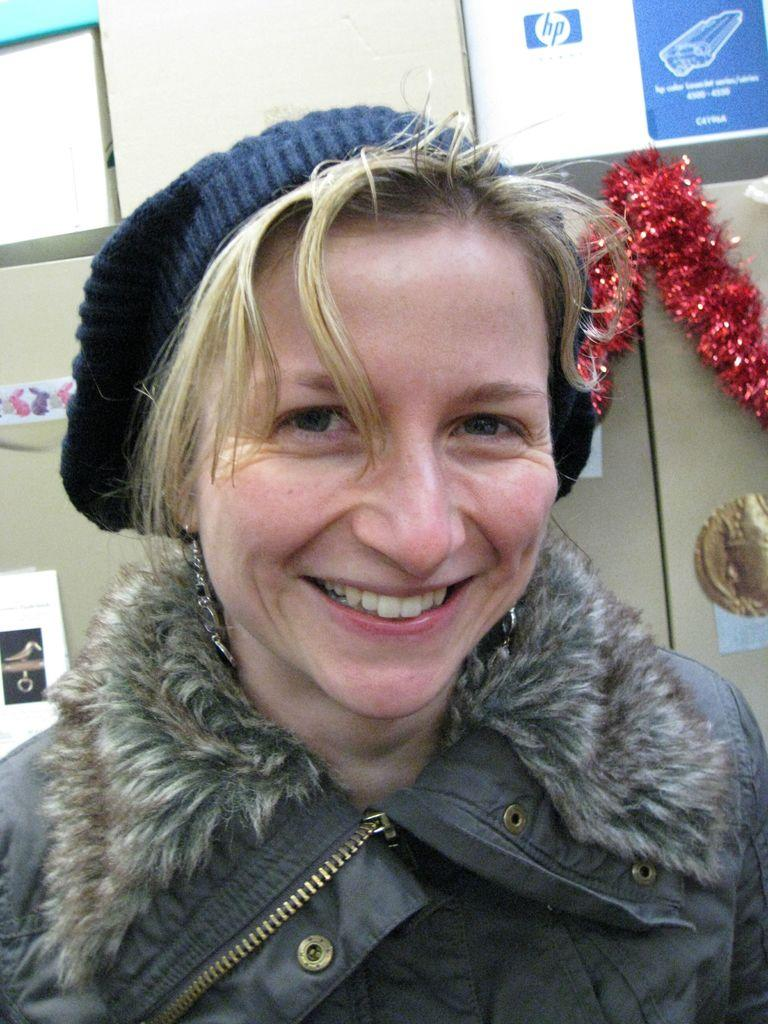Who is present in the image? There is a woman in the image. What is the woman's facial expression? The woman is smiling. What is the woman wearing on her head? The woman is wearing a cap. What can be seen in the background of the image? There is a wall in the background of the image. What is attached to the wall in the image? There is a decorative item attached to the wall. Can you tell me how deep the river is in the image? There is no river present in the image; it features a woman with a cap, a smiling expression, and a wall with a decorative item. 